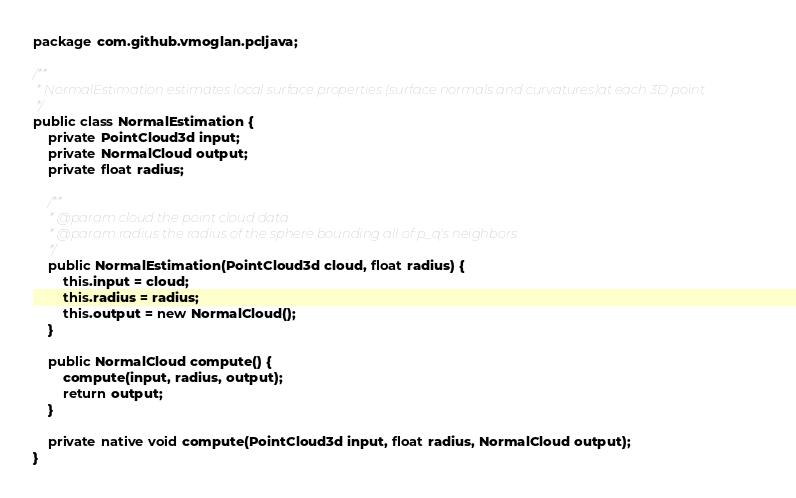<code> <loc_0><loc_0><loc_500><loc_500><_Java_>package com.github.vmoglan.pcljava;

/**
 * NormalEstimation estimates local surface properties (surface normals and curvatures)at each 3D point.
 */
public class NormalEstimation {
	private PointCloud3d input;
	private NormalCloud output;
	private float radius;
	
	/**
	 * @param cloud the point cloud data
	 * @param radius the radius of the sphere bounding all of p_q's neighbors
	 */
	public NormalEstimation(PointCloud3d cloud, float radius) {
		this.input = cloud;
		this.radius = radius;
		this.output = new NormalCloud();
	}

	public NormalCloud compute() {
		compute(input, radius, output);
		return output;
	}
	
	private native void compute(PointCloud3d input, float radius, NormalCloud output);
}
</code> 